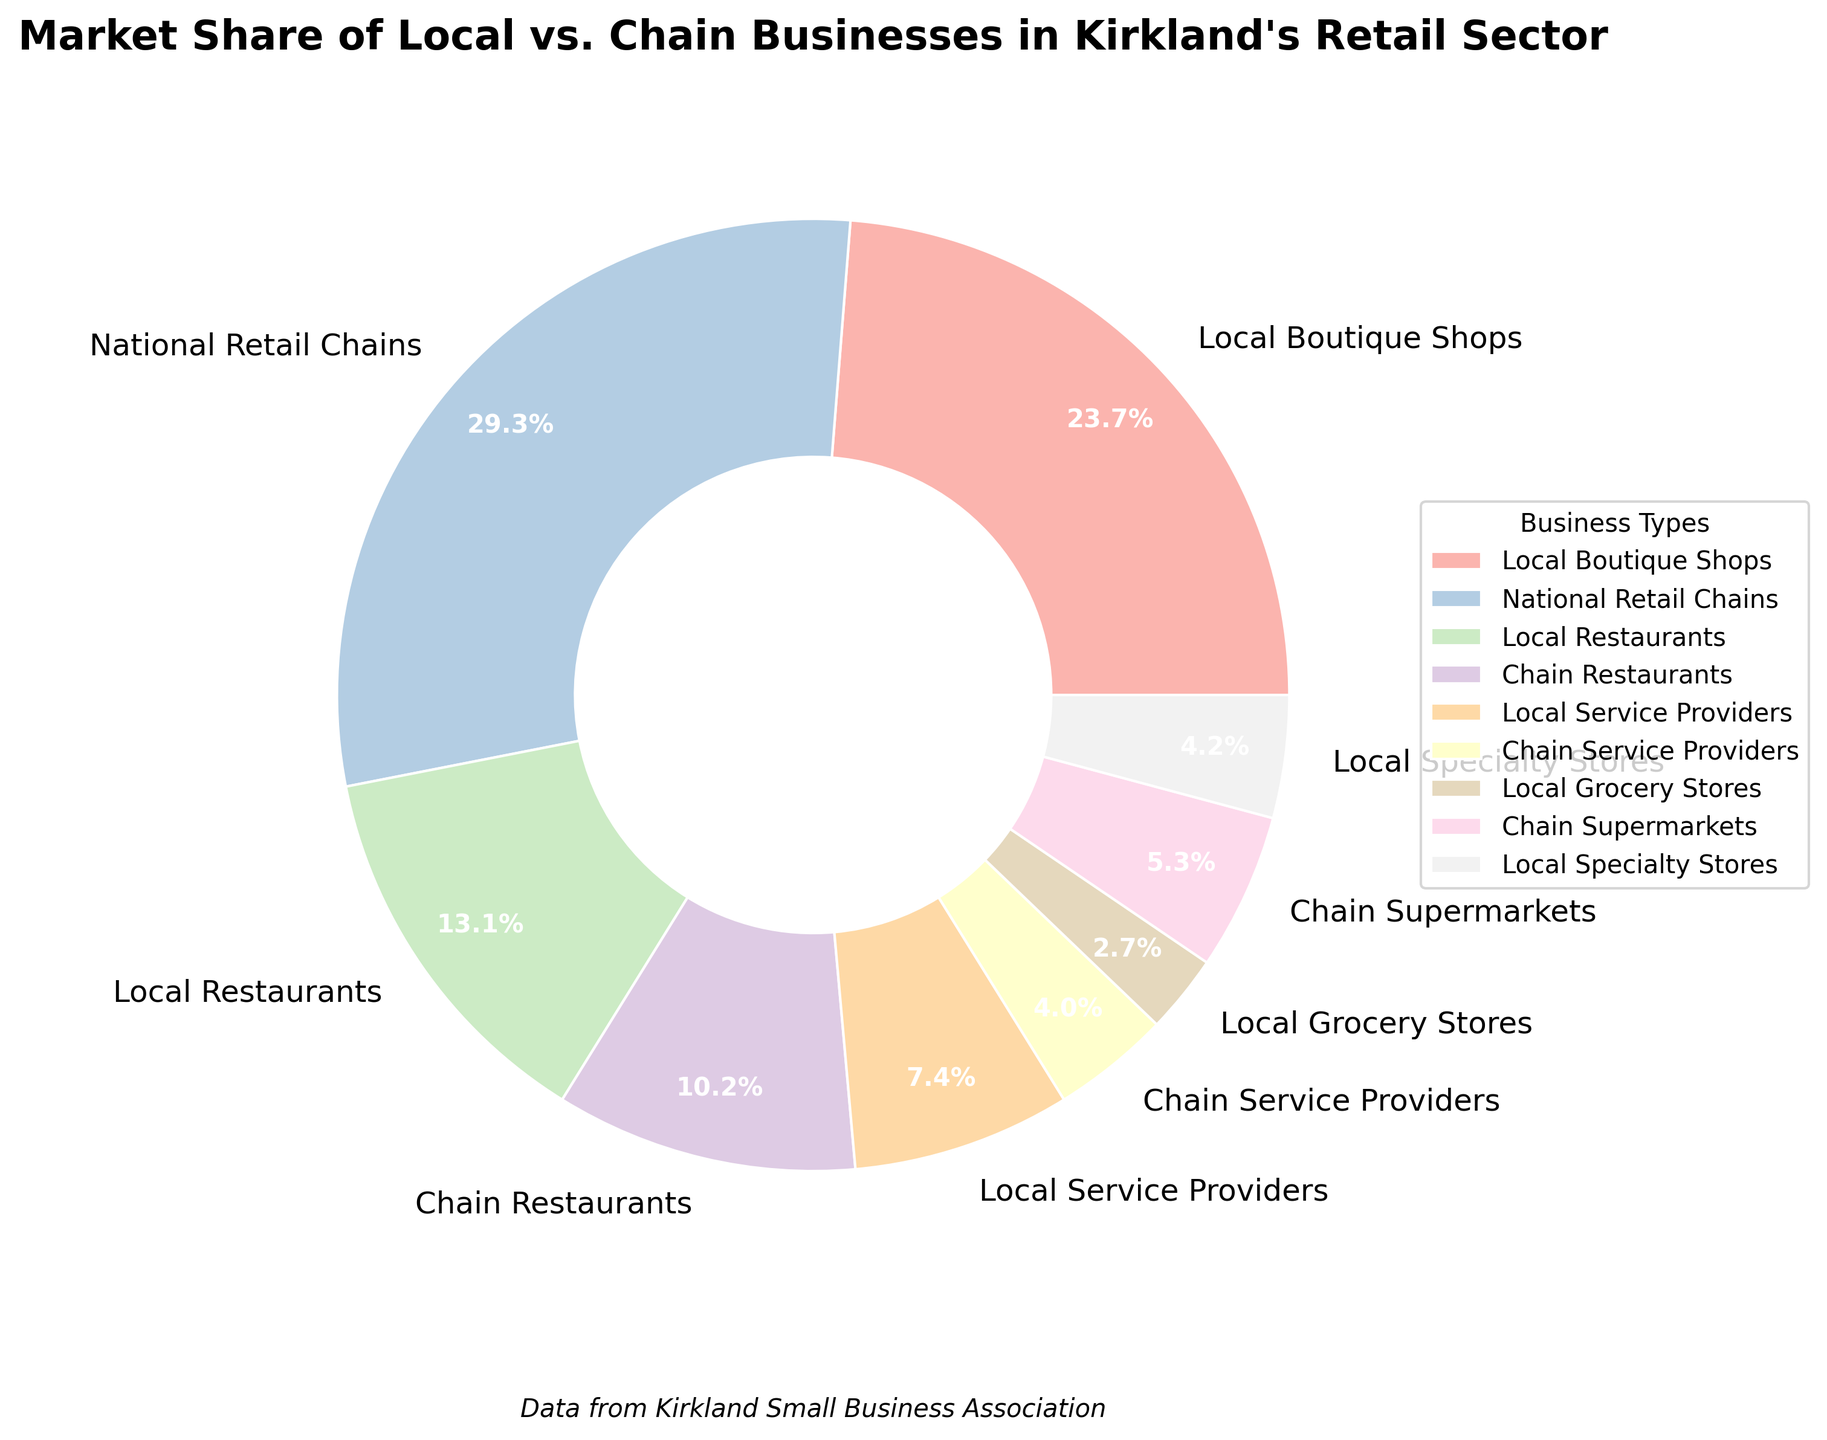What is the business type with the highest market share in Kirkland's retail sector? The figure shows that "National Retail Chains" occupies the largest portion of the pie chart.
Answer: National Retail Chains Which type of local business holds the smallest market share? Among the local business types represented in the pie chart, "Local Grocery Stores" has the smallest segment.
Answer: Local Grocery Stores What is the total market share of all local businesses combined? Sum up the market share percentages of all local business types: Local Boutique Shops (28.5) + Local Restaurants (15.7) + Local Service Providers (8.9) + Local Grocery Stores (3.2) + Local Specialty Stores (5.0) = 61.3%.
Answer: 61.3% How does the market share of local restaurants compare to chain restaurants? Local Restaurants have a market share of 15.7%, while Chain Restaurants have 12.3%. So, Local Restaurants have a higher market share than Chain Restaurants.
Answer: Local Restaurants have a higher market share Which business type has the smallest market share and what is its percentage? "Chain Service Providers" have the smallest market share with 4.8%.
Answer: Chain Service Providers, 4.8% What is the difference in market share between chain supermarkets and local grocery stores? Market share of Chain Supermarkets (6.4%) minus that of Local Grocery Stores (3.2%) equals 3.2%.
Answer: 3.2% What is the average market share of local service providers and local grocery stores? (Market share of Local Service Providers (8.9%) + Local Grocery Stores (3.2%)) / 2 = (8.9 + 3.2) / 2 = 6.05%.
Answer: 6.05% How much greater is the market share of national retail chains compared to chain restaurants? Market share of National Retail Chains (35.2%) minus Chain Restaurants (12.3%) equals 22.9%.
Answer: 22.9% What is the combined market share of both local and chain service providers? Sum the market shares of Local Service Providers (8.9%) and Chain Service Providers (4.8%) = 13.7%.
Answer: 13.7% Among the types of businesses listed, which type is represented by the lightest color, and what is its market share? According to the pie chart's color gradient, the lightest segment represents "Local Grocery Stores," with a market share of 3.2%.
Answer: Local Grocery Stores, 3.2% 